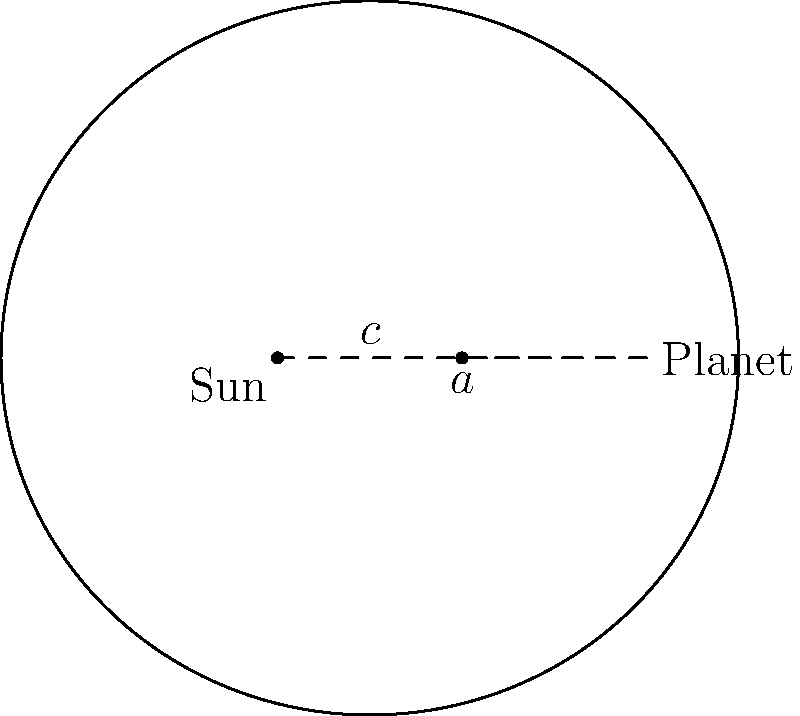In the elliptical orbit diagram shown, where $a$ represents the semi-major axis and $c$ is the distance from the center to a focus, what is the eccentricity ($e$) of the orbit in terms of $a$ and $c$? To find the eccentricity of an elliptical orbit, we can follow these steps:

1. Recall the definition of eccentricity for an ellipse:
   The eccentricity $e$ is the ratio of the distance between the foci to the length of the major axis.

2. In the diagram:
   - The distance between the foci is $2c$
   - The length of the major axis is $2a$

3. Therefore, the eccentricity can be expressed as:

   $$e = \frac{2c}{2a} = \frac{c}{a}$$

4. This ratio $\frac{c}{a}$ gives us the eccentricity of the elliptical orbit.

5. The eccentricity is always a value between 0 and 1 for elliptical orbits:
   - When $e = 0$, the orbit is perfectly circular
   - As $e$ approaches 1, the orbit becomes more elongated

6. In the context of planetary orbits, the eccentricity helps describe how much the planet's orbit deviates from a perfect circle.
Answer: $e = \frac{c}{a}$ 